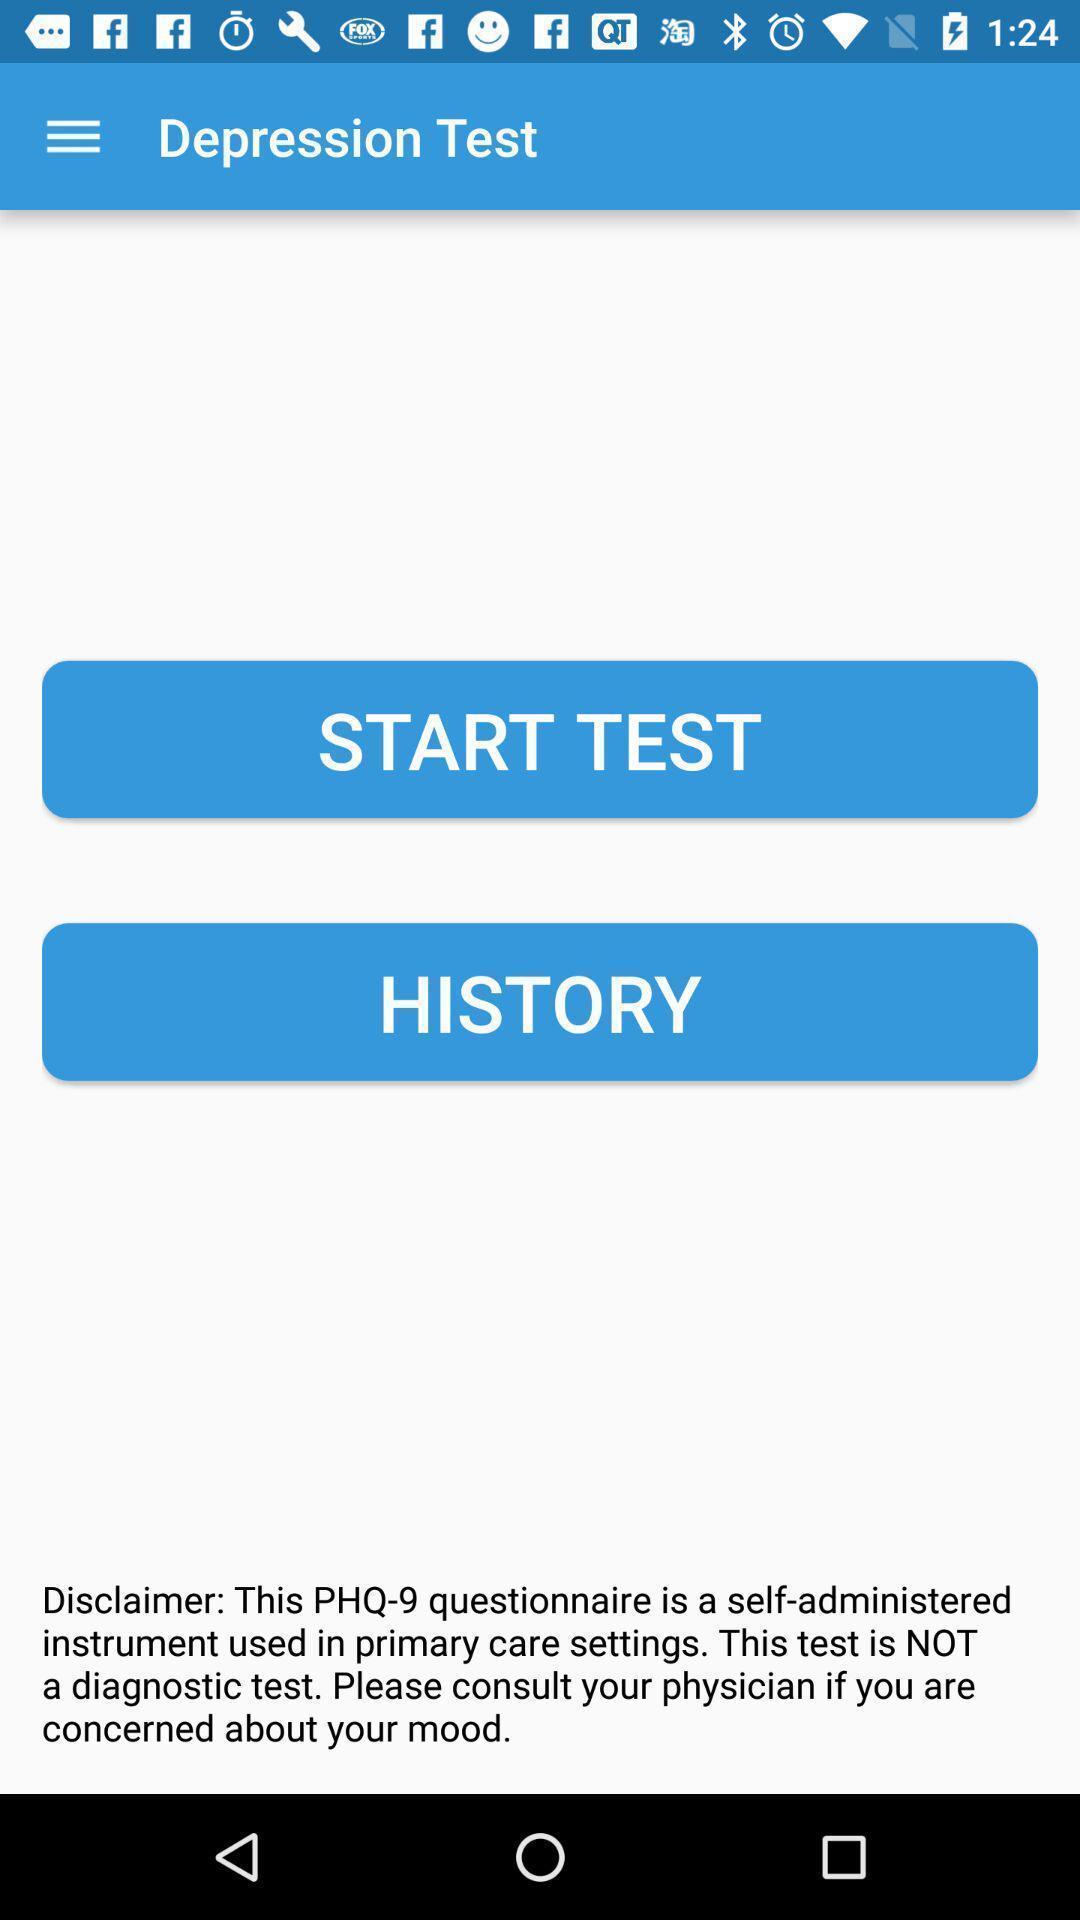Describe the visual elements of this screenshot. Screen showing about depression test. 